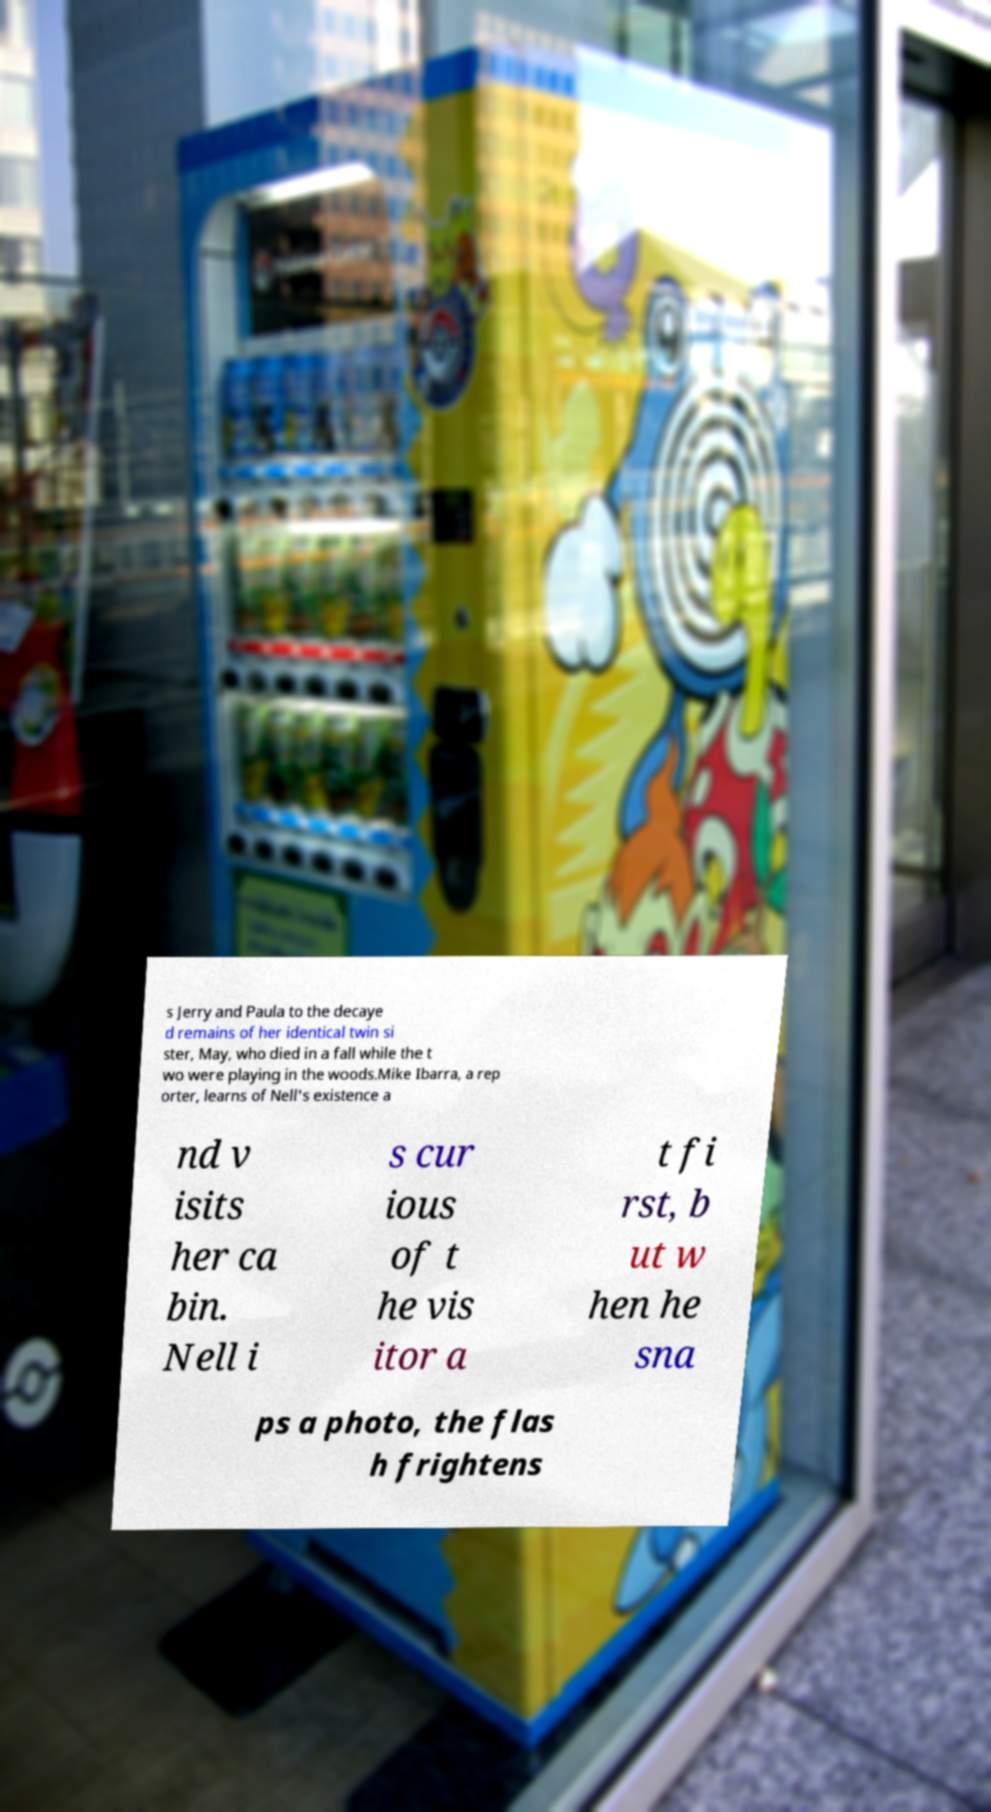Please read and relay the text visible in this image. What does it say? s Jerry and Paula to the decaye d remains of her identical twin si ster, May, who died in a fall while the t wo were playing in the woods.Mike Ibarra, a rep orter, learns of Nell's existence a nd v isits her ca bin. Nell i s cur ious of t he vis itor a t fi rst, b ut w hen he sna ps a photo, the flas h frightens 